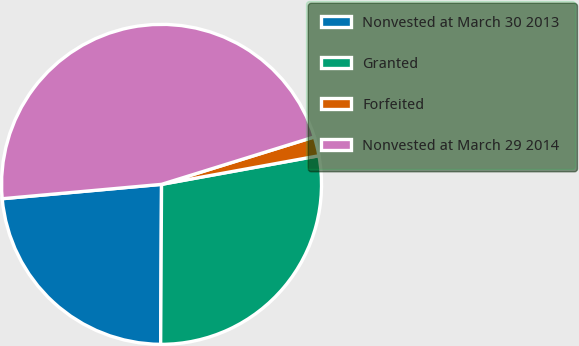<chart> <loc_0><loc_0><loc_500><loc_500><pie_chart><fcel>Nonvested at March 30 2013<fcel>Granted<fcel>Forfeited<fcel>Nonvested at March 29 2014<nl><fcel>23.48%<fcel>27.95%<fcel>1.93%<fcel>46.64%<nl></chart> 